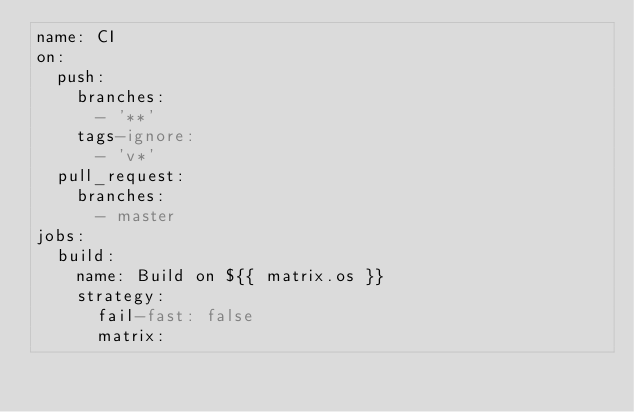Convert code to text. <code><loc_0><loc_0><loc_500><loc_500><_YAML_>name: CI
on:
  push:
    branches:
      - '**'
    tags-ignore:
      - 'v*'
  pull_request:
    branches:
      - master
jobs:
  build:
    name: Build on ${{ matrix.os }}
    strategy:
      fail-fast: false
      matrix:</code> 